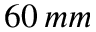Convert formula to latex. <formula><loc_0><loc_0><loc_500><loc_500>6 0 \, m m</formula> 